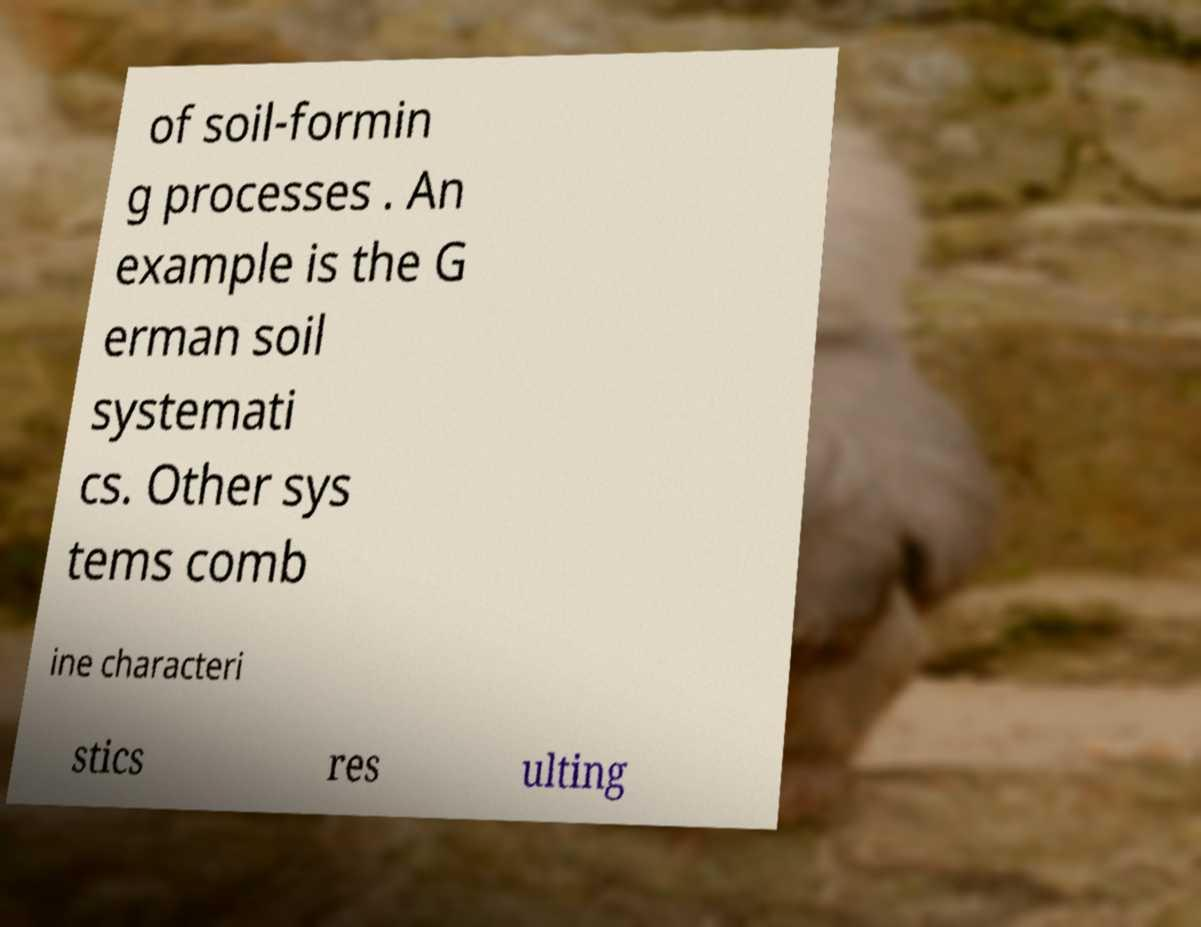I need the written content from this picture converted into text. Can you do that? of soil-formin g processes . An example is the G erman soil systemati cs. Other sys tems comb ine characteri stics res ulting 